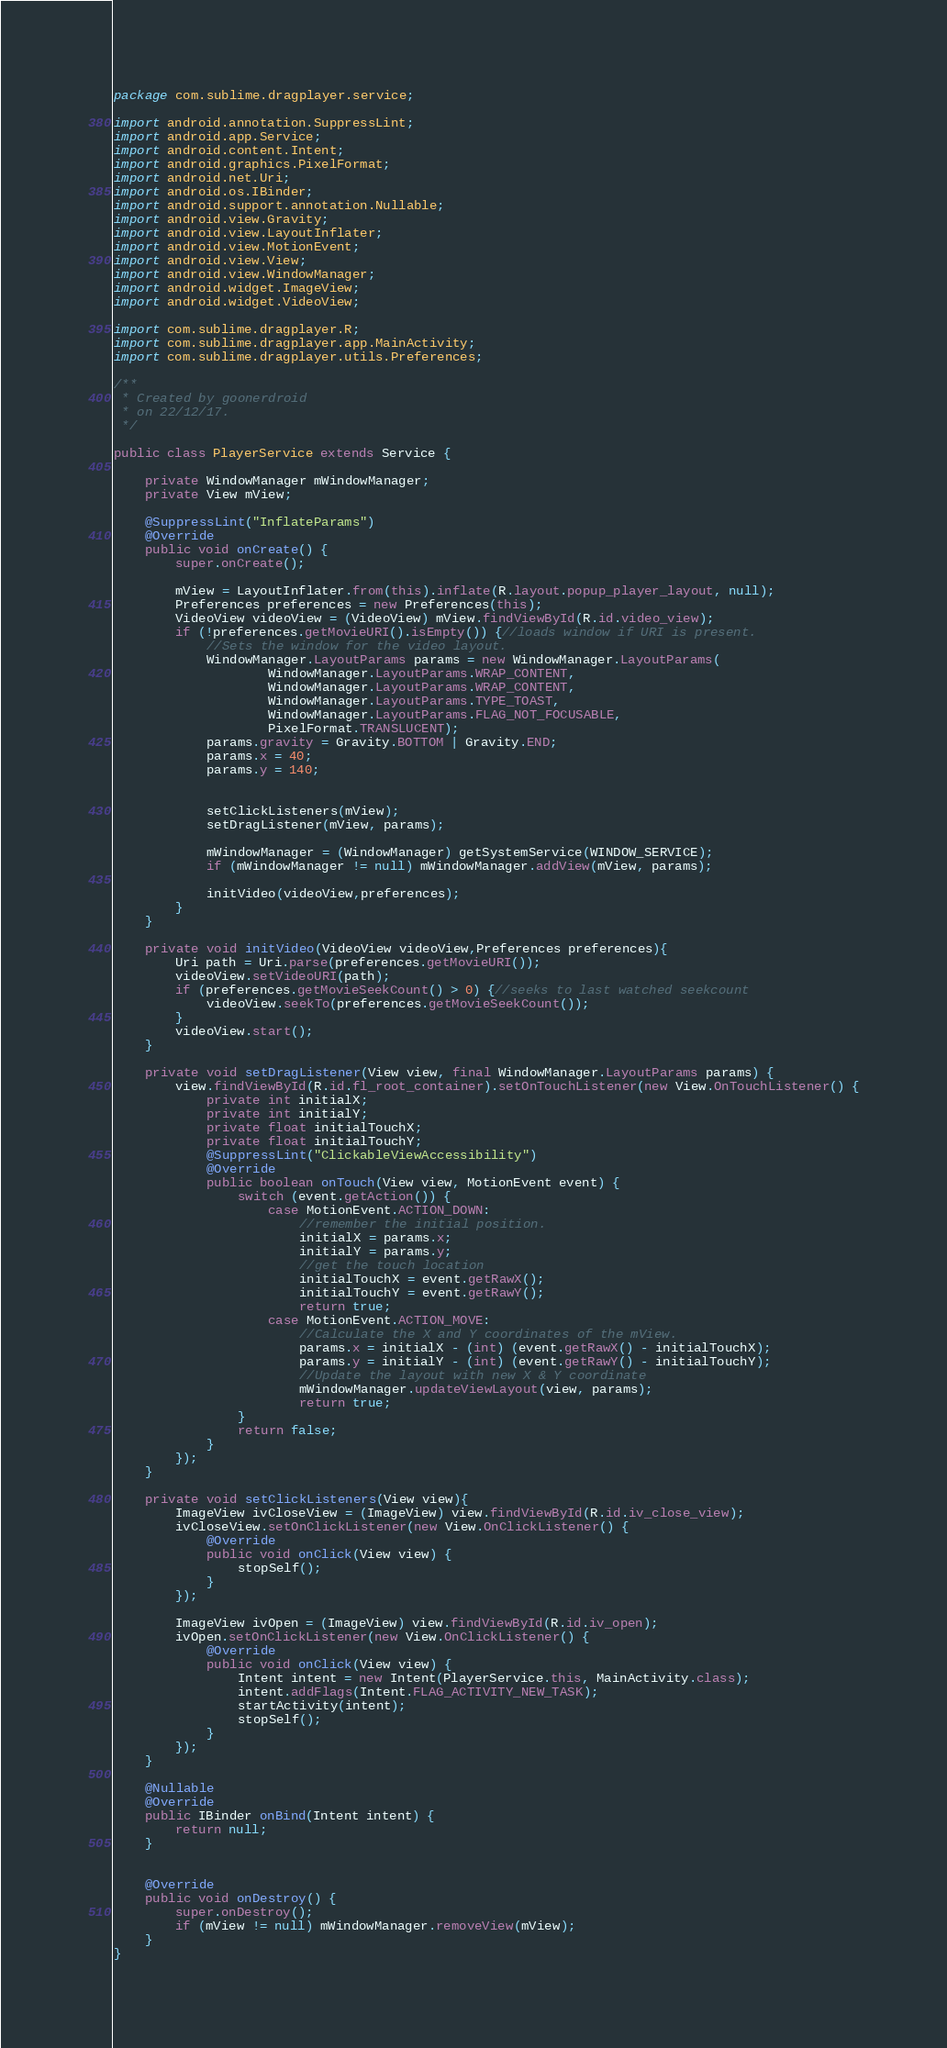<code> <loc_0><loc_0><loc_500><loc_500><_Java_>package com.sublime.dragplayer.service;

import android.annotation.SuppressLint;
import android.app.Service;
import android.content.Intent;
import android.graphics.PixelFormat;
import android.net.Uri;
import android.os.IBinder;
import android.support.annotation.Nullable;
import android.view.Gravity;
import android.view.LayoutInflater;
import android.view.MotionEvent;
import android.view.View;
import android.view.WindowManager;
import android.widget.ImageView;
import android.widget.VideoView;

import com.sublime.dragplayer.R;
import com.sublime.dragplayer.app.MainActivity;
import com.sublime.dragplayer.utils.Preferences;

/**
 * Created by goonerdroid
 * on 22/12/17.
 */

public class PlayerService extends Service {

    private WindowManager mWindowManager;
    private View mView;

    @SuppressLint("InflateParams")
    @Override
    public void onCreate() {
        super.onCreate();

        mView = LayoutInflater.from(this).inflate(R.layout.popup_player_layout, null);
        Preferences preferences = new Preferences(this);
        VideoView videoView = (VideoView) mView.findViewById(R.id.video_view);
        if (!preferences.getMovieURI().isEmpty()) {//loads window if URI is present.
            //Sets the window for the video layout.
            WindowManager.LayoutParams params = new WindowManager.LayoutParams(
                    WindowManager.LayoutParams.WRAP_CONTENT,
                    WindowManager.LayoutParams.WRAP_CONTENT,
                    WindowManager.LayoutParams.TYPE_TOAST,
                    WindowManager.LayoutParams.FLAG_NOT_FOCUSABLE,
                    PixelFormat.TRANSLUCENT);
            params.gravity = Gravity.BOTTOM | Gravity.END;
            params.x = 40;
            params.y = 140;


            setClickListeners(mView);
            setDragListener(mView, params);

            mWindowManager = (WindowManager) getSystemService(WINDOW_SERVICE);
            if (mWindowManager != null) mWindowManager.addView(mView, params);

            initVideo(videoView,preferences);
        }
    }

    private void initVideo(VideoView videoView,Preferences preferences){
        Uri path = Uri.parse(preferences.getMovieURI());
        videoView.setVideoURI(path);
        if (preferences.getMovieSeekCount() > 0) {//seeks to last watched seekcount
            videoView.seekTo(preferences.getMovieSeekCount());
        }
        videoView.start();
    }

    private void setDragListener(View view, final WindowManager.LayoutParams params) {
        view.findViewById(R.id.fl_root_container).setOnTouchListener(new View.OnTouchListener() {
            private int initialX;
            private int initialY;
            private float initialTouchX;
            private float initialTouchY;
            @SuppressLint("ClickableViewAccessibility")
            @Override
            public boolean onTouch(View view, MotionEvent event) {
                switch (event.getAction()) {
                    case MotionEvent.ACTION_DOWN:
                        //remember the initial position.
                        initialX = params.x;
                        initialY = params.y;
                        //get the touch location
                        initialTouchX = event.getRawX();
                        initialTouchY = event.getRawY();
                        return true;
                    case MotionEvent.ACTION_MOVE:
                        //Calculate the X and Y coordinates of the mView.
                        params.x = initialX - (int) (event.getRawX() - initialTouchX);
                        params.y = initialY - (int) (event.getRawY() - initialTouchY);
                        //Update the layout with new X & Y coordinate
                        mWindowManager.updateViewLayout(view, params);
                        return true;
                }
                return false;
            }
        });
    }

    private void setClickListeners(View view){
        ImageView ivCloseView = (ImageView) view.findViewById(R.id.iv_close_view);
        ivCloseView.setOnClickListener(new View.OnClickListener() {
            @Override
            public void onClick(View view) {
                stopSelf();
            }
        });

        ImageView ivOpen = (ImageView) view.findViewById(R.id.iv_open);
        ivOpen.setOnClickListener(new View.OnClickListener() {
            @Override
            public void onClick(View view) {
                Intent intent = new Intent(PlayerService.this, MainActivity.class);
                intent.addFlags(Intent.FLAG_ACTIVITY_NEW_TASK);
                startActivity(intent);
                stopSelf();
            }
        });
    }

    @Nullable
    @Override
    public IBinder onBind(Intent intent) {
        return null;
    }


    @Override
    public void onDestroy() {
        super.onDestroy();
        if (mView != null) mWindowManager.removeView(mView);
    }
}
</code> 